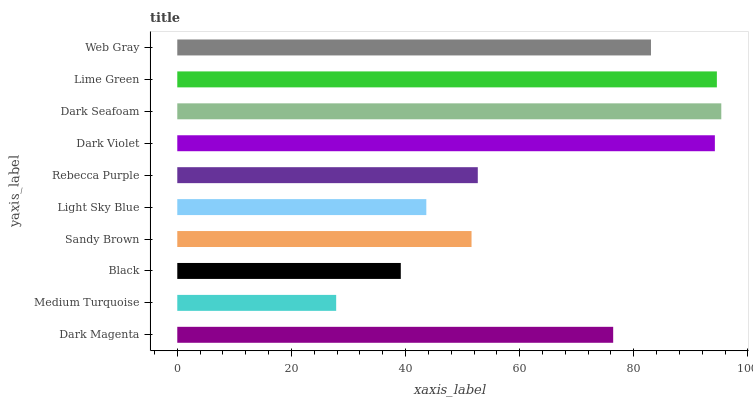Is Medium Turquoise the minimum?
Answer yes or no. Yes. Is Dark Seafoam the maximum?
Answer yes or no. Yes. Is Black the minimum?
Answer yes or no. No. Is Black the maximum?
Answer yes or no. No. Is Black greater than Medium Turquoise?
Answer yes or no. Yes. Is Medium Turquoise less than Black?
Answer yes or no. Yes. Is Medium Turquoise greater than Black?
Answer yes or no. No. Is Black less than Medium Turquoise?
Answer yes or no. No. Is Dark Magenta the high median?
Answer yes or no. Yes. Is Rebecca Purple the low median?
Answer yes or no. Yes. Is Black the high median?
Answer yes or no. No. Is Dark Violet the low median?
Answer yes or no. No. 